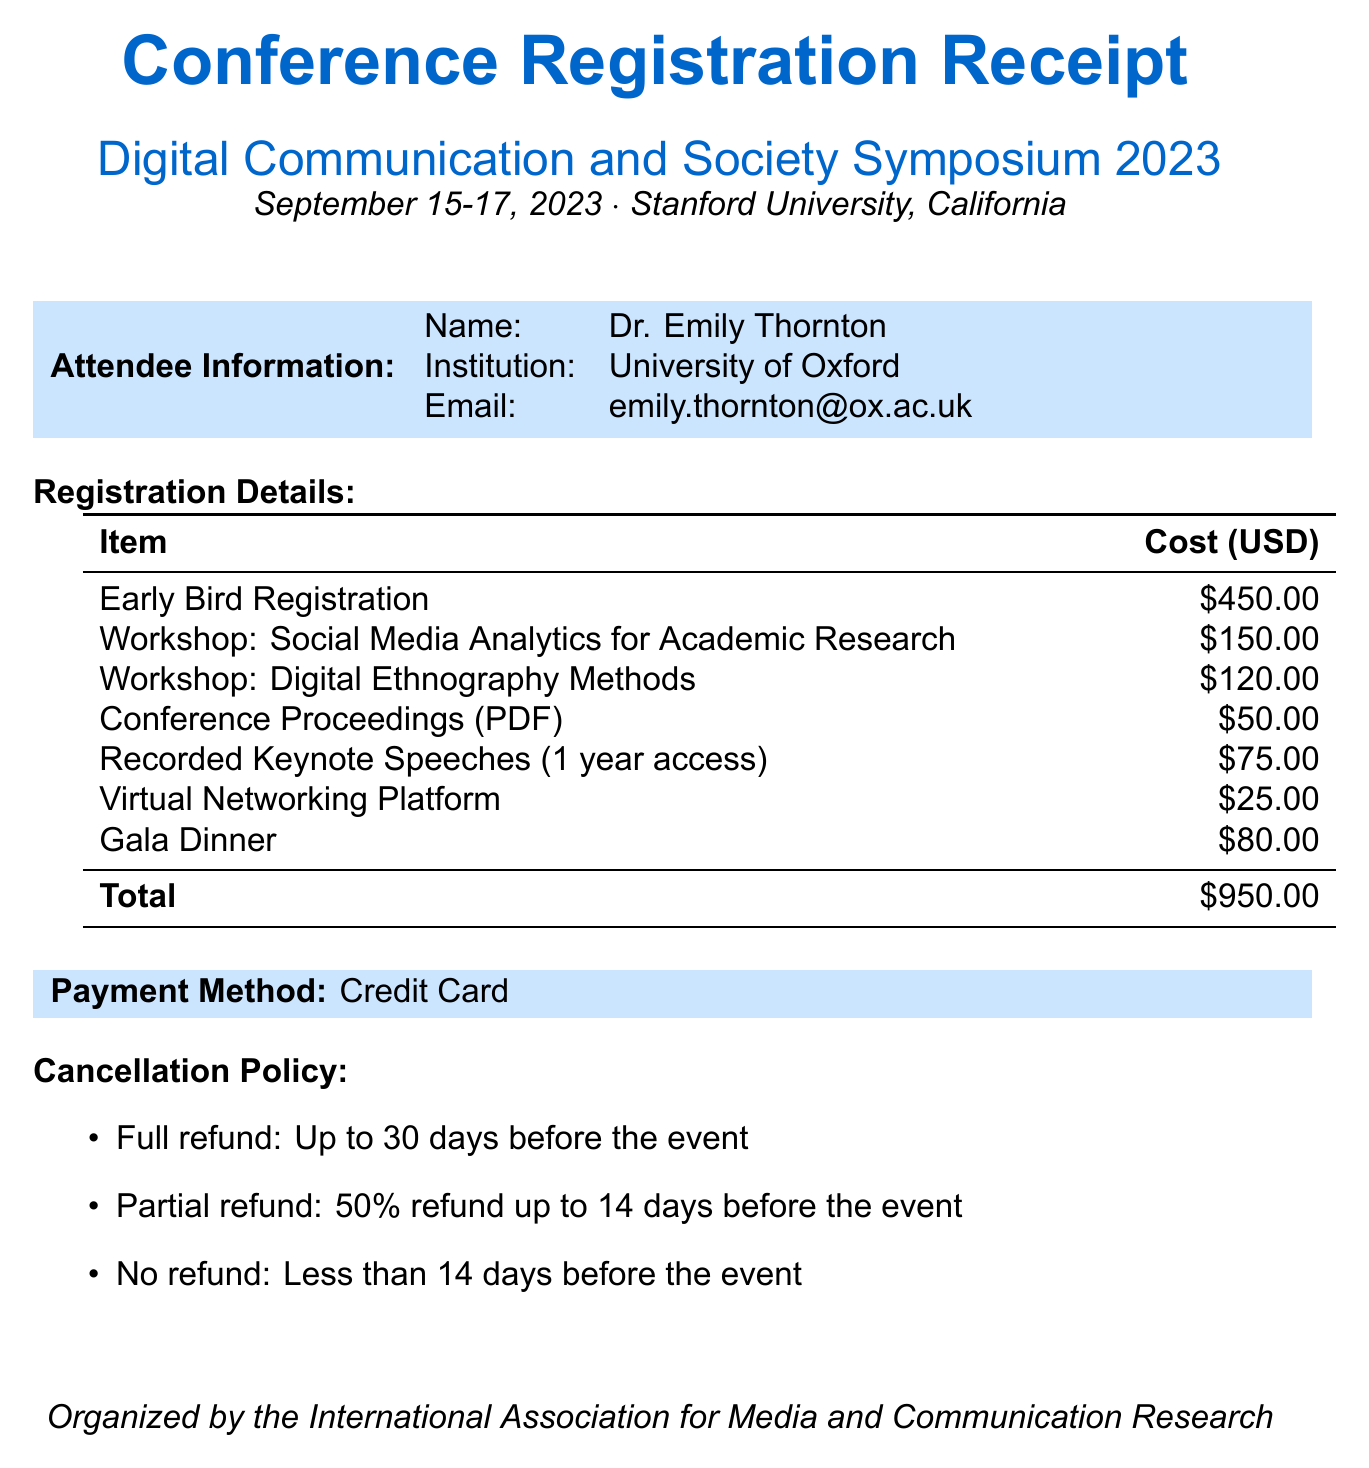What is the name of the conference? The name of the conference is mentioned in the document as "Digital Communication and Society Symposium 2023."
Answer: Digital Communication and Society Symposium 2023 Who is the instructor for the workshop on "Digital Ethnography Methods"? The document specifies the instructor for this workshop as "Prof. Sarah Johnson, MIT."
Answer: Prof. Sarah Johnson, MIT What is the total cost of registration and workshops? The total cost is derived from summing the registration fee and the workshop costs, which is $450 + $150 + $120 = $720.
Answer: $950.00 What type of access is provided for the "Recorded Keynote Speeches"? The access type for this digital material is mentioned as "1 year."
Answer: 1 year What is the cancellation policy for a refund if canceled less than 14 days before the event? The document states that if canceled less than 14 days before the event, there is "No refund."
Answer: No refund What is the cost of the Gala Dinner? The cost of the Gala Dinner is explicitly listed in the document as "$80."
Answer: $80 